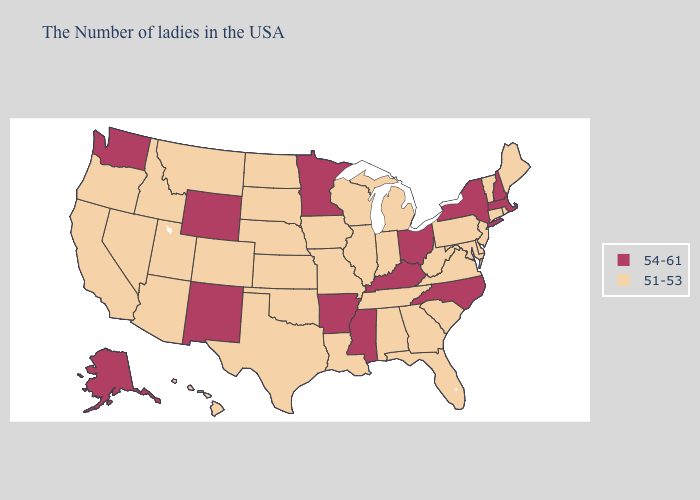Does the map have missing data?
Quick response, please. No. What is the lowest value in states that border Oklahoma?
Give a very brief answer. 51-53. Name the states that have a value in the range 54-61?
Answer briefly. Massachusetts, New Hampshire, New York, North Carolina, Ohio, Kentucky, Mississippi, Arkansas, Minnesota, Wyoming, New Mexico, Washington, Alaska. Does Virginia have the lowest value in the USA?
Keep it brief. Yes. Which states hav the highest value in the Northeast?
Answer briefly. Massachusetts, New Hampshire, New York. Name the states that have a value in the range 54-61?
Give a very brief answer. Massachusetts, New Hampshire, New York, North Carolina, Ohio, Kentucky, Mississippi, Arkansas, Minnesota, Wyoming, New Mexico, Washington, Alaska. Among the states that border Tennessee , does Virginia have the lowest value?
Quick response, please. Yes. What is the value of New York?
Concise answer only. 54-61. What is the lowest value in states that border Maine?
Concise answer only. 54-61. What is the highest value in the MidWest ?
Answer briefly. 54-61. What is the value of Illinois?
Quick response, please. 51-53. What is the value of Connecticut?
Give a very brief answer. 51-53. What is the value of Minnesota?
Keep it brief. 54-61. Which states have the lowest value in the USA?
Be succinct. Maine, Rhode Island, Vermont, Connecticut, New Jersey, Delaware, Maryland, Pennsylvania, Virginia, South Carolina, West Virginia, Florida, Georgia, Michigan, Indiana, Alabama, Tennessee, Wisconsin, Illinois, Louisiana, Missouri, Iowa, Kansas, Nebraska, Oklahoma, Texas, South Dakota, North Dakota, Colorado, Utah, Montana, Arizona, Idaho, Nevada, California, Oregon, Hawaii. Which states have the lowest value in the USA?
Short answer required. Maine, Rhode Island, Vermont, Connecticut, New Jersey, Delaware, Maryland, Pennsylvania, Virginia, South Carolina, West Virginia, Florida, Georgia, Michigan, Indiana, Alabama, Tennessee, Wisconsin, Illinois, Louisiana, Missouri, Iowa, Kansas, Nebraska, Oklahoma, Texas, South Dakota, North Dakota, Colorado, Utah, Montana, Arizona, Idaho, Nevada, California, Oregon, Hawaii. 